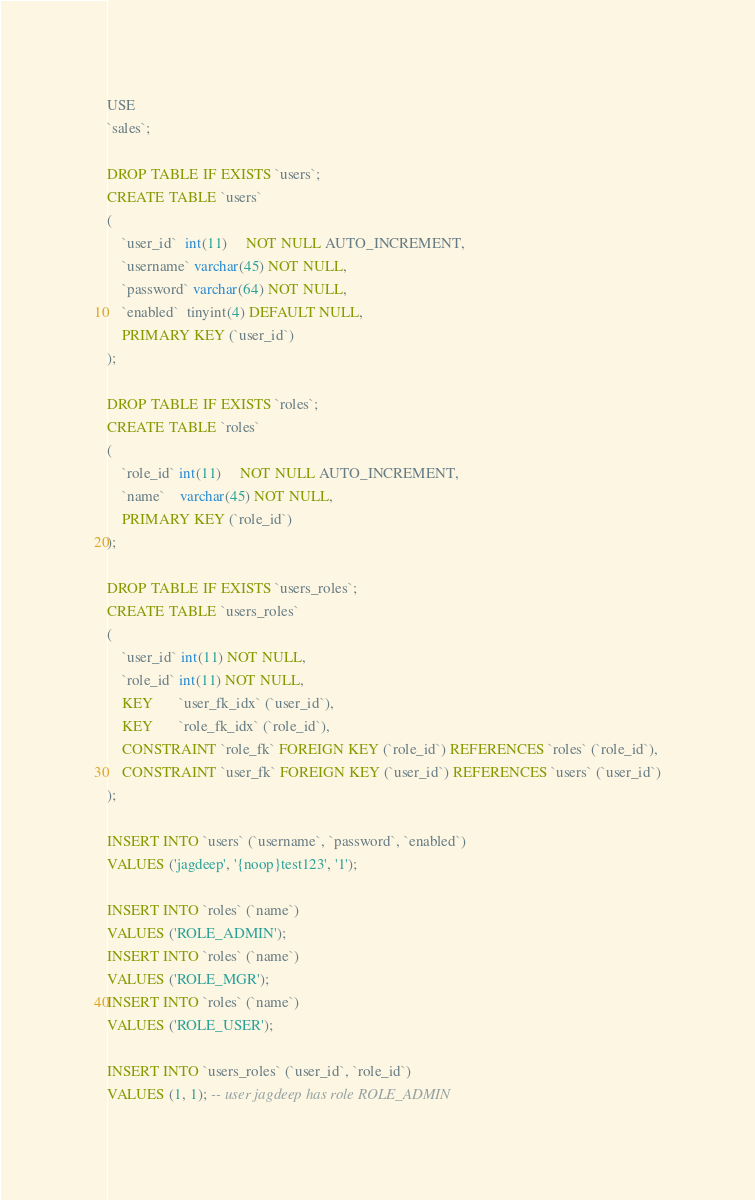<code> <loc_0><loc_0><loc_500><loc_500><_SQL_>USE
`sales`;

DROP TABLE IF EXISTS `users`;
CREATE TABLE `users`
(
    `user_id`  int(11)     NOT NULL AUTO_INCREMENT,
    `username` varchar(45) NOT NULL,
    `password` varchar(64) NOT NULL,
    `enabled`  tinyint(4) DEFAULT NULL,
    PRIMARY KEY (`user_id`)
);

DROP TABLE IF EXISTS `roles`;
CREATE TABLE `roles`
(
    `role_id` int(11)     NOT NULL AUTO_INCREMENT,
    `name`    varchar(45) NOT NULL,
    PRIMARY KEY (`role_id`)
);

DROP TABLE IF EXISTS `users_roles`;
CREATE TABLE `users_roles`
(
    `user_id` int(11) NOT NULL,
    `role_id` int(11) NOT NULL,
    KEY       `user_fk_idx` (`user_id`),
    KEY       `role_fk_idx` (`role_id`),
    CONSTRAINT `role_fk` FOREIGN KEY (`role_id`) REFERENCES `roles` (`role_id`),
    CONSTRAINT `user_fk` FOREIGN KEY (`user_id`) REFERENCES `users` (`user_id`)
);

INSERT INTO `users` (`username`, `password`, `enabled`)
VALUES ('jagdeep', '{noop}test123', '1');

INSERT INTO `roles` (`name`)
VALUES ('ROLE_ADMIN');
INSERT INTO `roles` (`name`)
VALUES ('ROLE_MGR');
INSERT INTO `roles` (`name`)
VALUES ('ROLE_USER');

INSERT INTO `users_roles` (`user_id`, `role_id`)
VALUES (1, 1); -- user jagdeep has role ROLE_ADMIN

</code> 